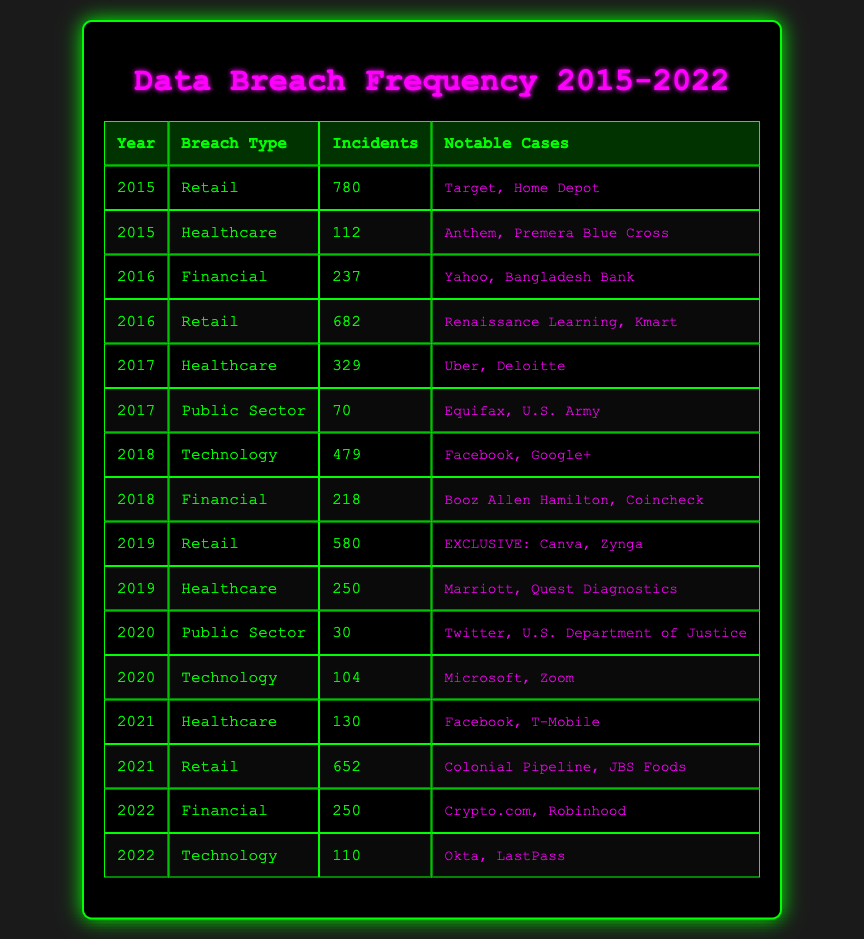What was the total number of retail incidents reported from 2015 to 2022? To find the total number of retail incidents, I will sum the incidents from each year: 780 (2015) + 682 (2016) + 580 (2019) + 652 (2021) = 2794. Thus, the total incidents across all retail breaches from 2015 to 2022 is 2794.
Answer: 2794 Which year had the highest number of healthcare incidents, and how many were there? Looking at the healthcare breach types, I can see the incidents for each year: 112 (2015), 329 (2017), 250 (2019), and 130 (2021). The highest number appears in 2017 with 329 incidents.
Answer: 2017, 329 Did the public sector experience more incidents in 2020 than in 2017? The table shows that in 2020, the public sector had 30 incidents, while in 2017, it had 70. Since 30 is less than 70, the public sector did not experience more incidents in 2020 than in 2017.
Answer: No What is the average number of technology-related breaches from 2018 to 2022? The incidents for technology-related breaches are: 479 (2018), 104 (2020), and 110 (2022). I'll sum these numbers: 479 + 104 + 110 = 693. Dividing by 3 (the count of years) gives 693 / 3 = 231. The average number of technology-related breaches from 2018 to 2022 is 231.
Answer: 231 How many incidents were reported in the financial sector in total from 2016 to 2022? The financial incidents from 2016 to 2022 are 237 (2016), 218 (2018), and 250 (2022). Adding these values gives: 237 + 218 + 250 = 705. Therefore, the total incidents in the financial sector from 2016 to 2022 are 705.
Answer: 705 Was there a year without any incidents reported in the healthcare sector? From the table, I can see healthcare incidents reported for the years 2015 (112), 2017 (329), 2019 (250), and 2021 (130), but no incidents are listed for 2016 and 2020. Thus, there were years without reported incidents in the healthcare sector.
Answer: Yes Which breach type had the least number of incidents in a single year? Reviewing the data, the least number of incidents is from the public sector in 2020, with only 30 incidents. Thus, the breach type with the least number of incidents in a single year is the public sector.
Answer: Public Sector, 30 In which year did the number of retail incidents decrease compared to the previous year? Checking the retail incidents for each year: 2015 (780), 2016 (682, which is a decrease from 2015), 2019 (580, a further decrease from 2016), and 2021 (652, which is an increase). The years where retail incidents decreased compared to the previous year are 2016 and 2019.
Answer: 2016 and 2019 